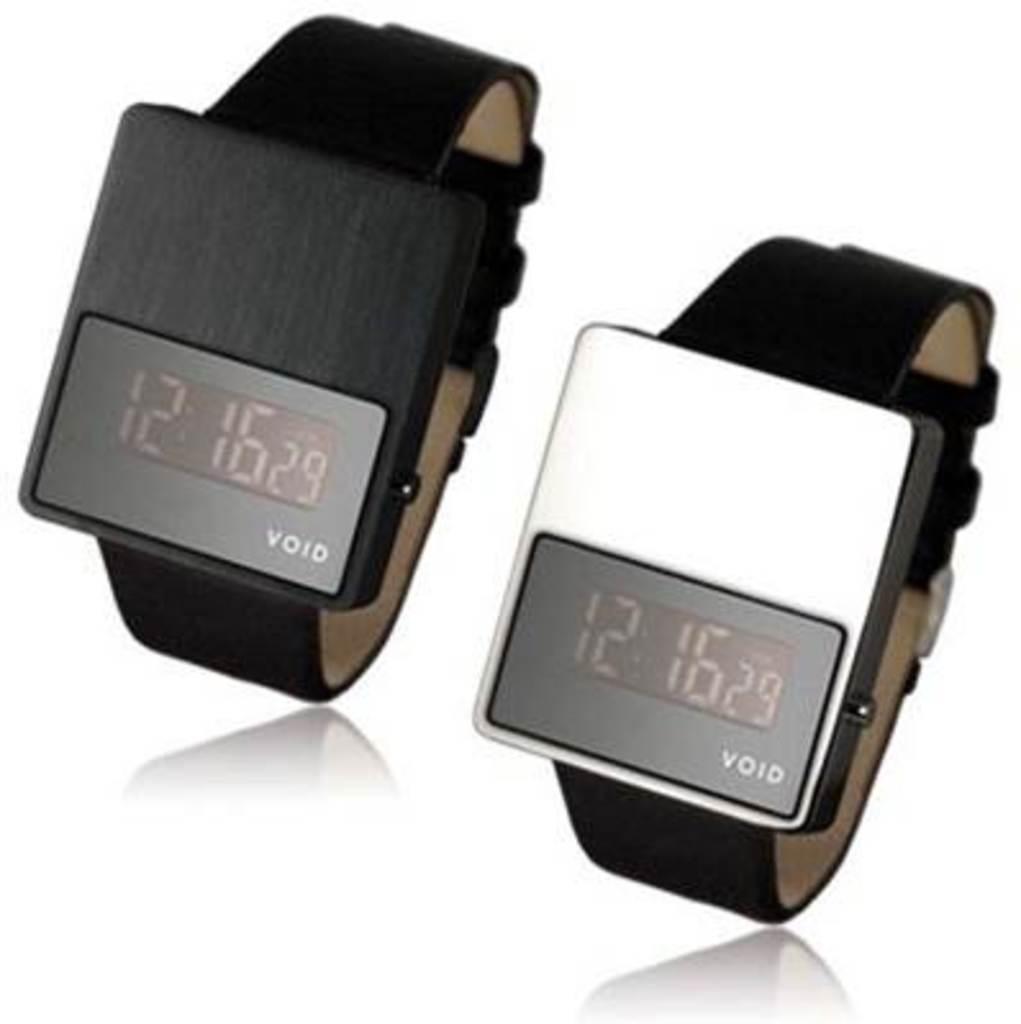What is the time on the watch?
Provide a short and direct response. 12:16. What is the company name who makes these watches?
Ensure brevity in your answer.  Void. 